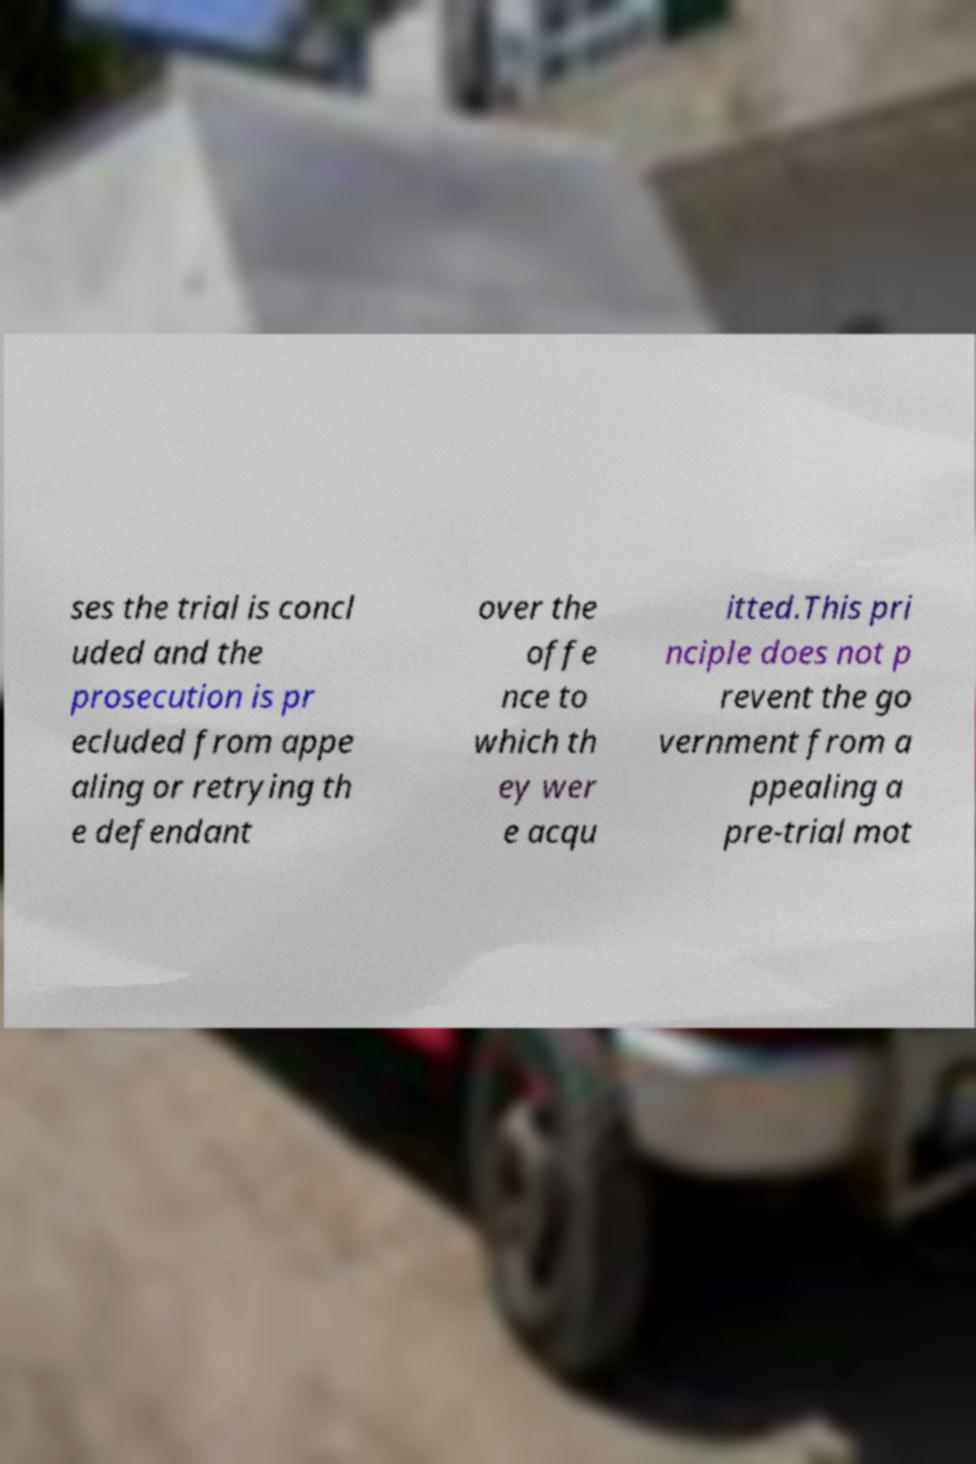Please read and relay the text visible in this image. What does it say? ses the trial is concl uded and the prosecution is pr ecluded from appe aling or retrying th e defendant over the offe nce to which th ey wer e acqu itted.This pri nciple does not p revent the go vernment from a ppealing a pre-trial mot 